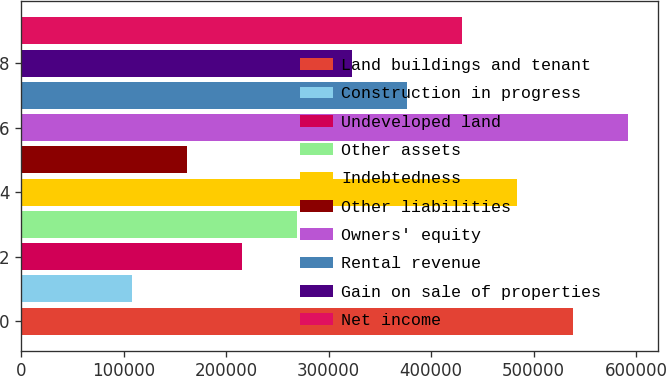Convert chart. <chart><loc_0><loc_0><loc_500><loc_500><bar_chart><fcel>Land buildings and tenant<fcel>Construction in progress<fcel>Undeveloped land<fcel>Other assets<fcel>Indebtedness<fcel>Other liabilities<fcel>Owners' equity<fcel>Rental revenue<fcel>Gain on sale of properties<fcel>Net income<nl><fcel>537925<fcel>107657<fcel>215224<fcel>269008<fcel>484142<fcel>161441<fcel>591709<fcel>376575<fcel>322791<fcel>430358<nl></chart> 